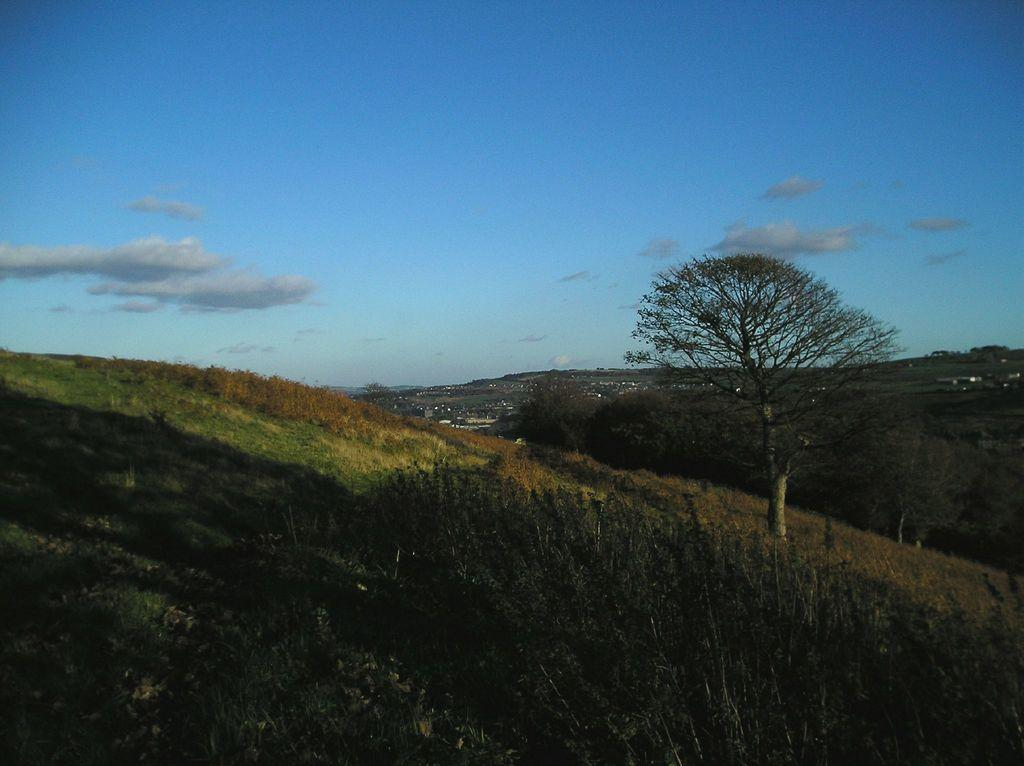What type of vegetation can be seen in the image? There are trees and grass in the image. What type of natural landform is visible in the image? There are mountains in the image. What is visible in the background of the image? The sky is visible in the background of the image. What can be seen in the sky in the image? Clouds are present in the sky. Can you tell me where the doctor is standing in the image? There is no doctor present in the image. What type of sea creature can be seen swimming in the grass in the image? There are no sea creatures, such as jellyfish, present in the image. 